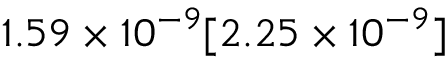<formula> <loc_0><loc_0><loc_500><loc_500>1 . 5 9 \times 1 0 ^ { - 9 } [ 2 . 2 5 \times 1 0 ^ { - 9 } ]</formula> 